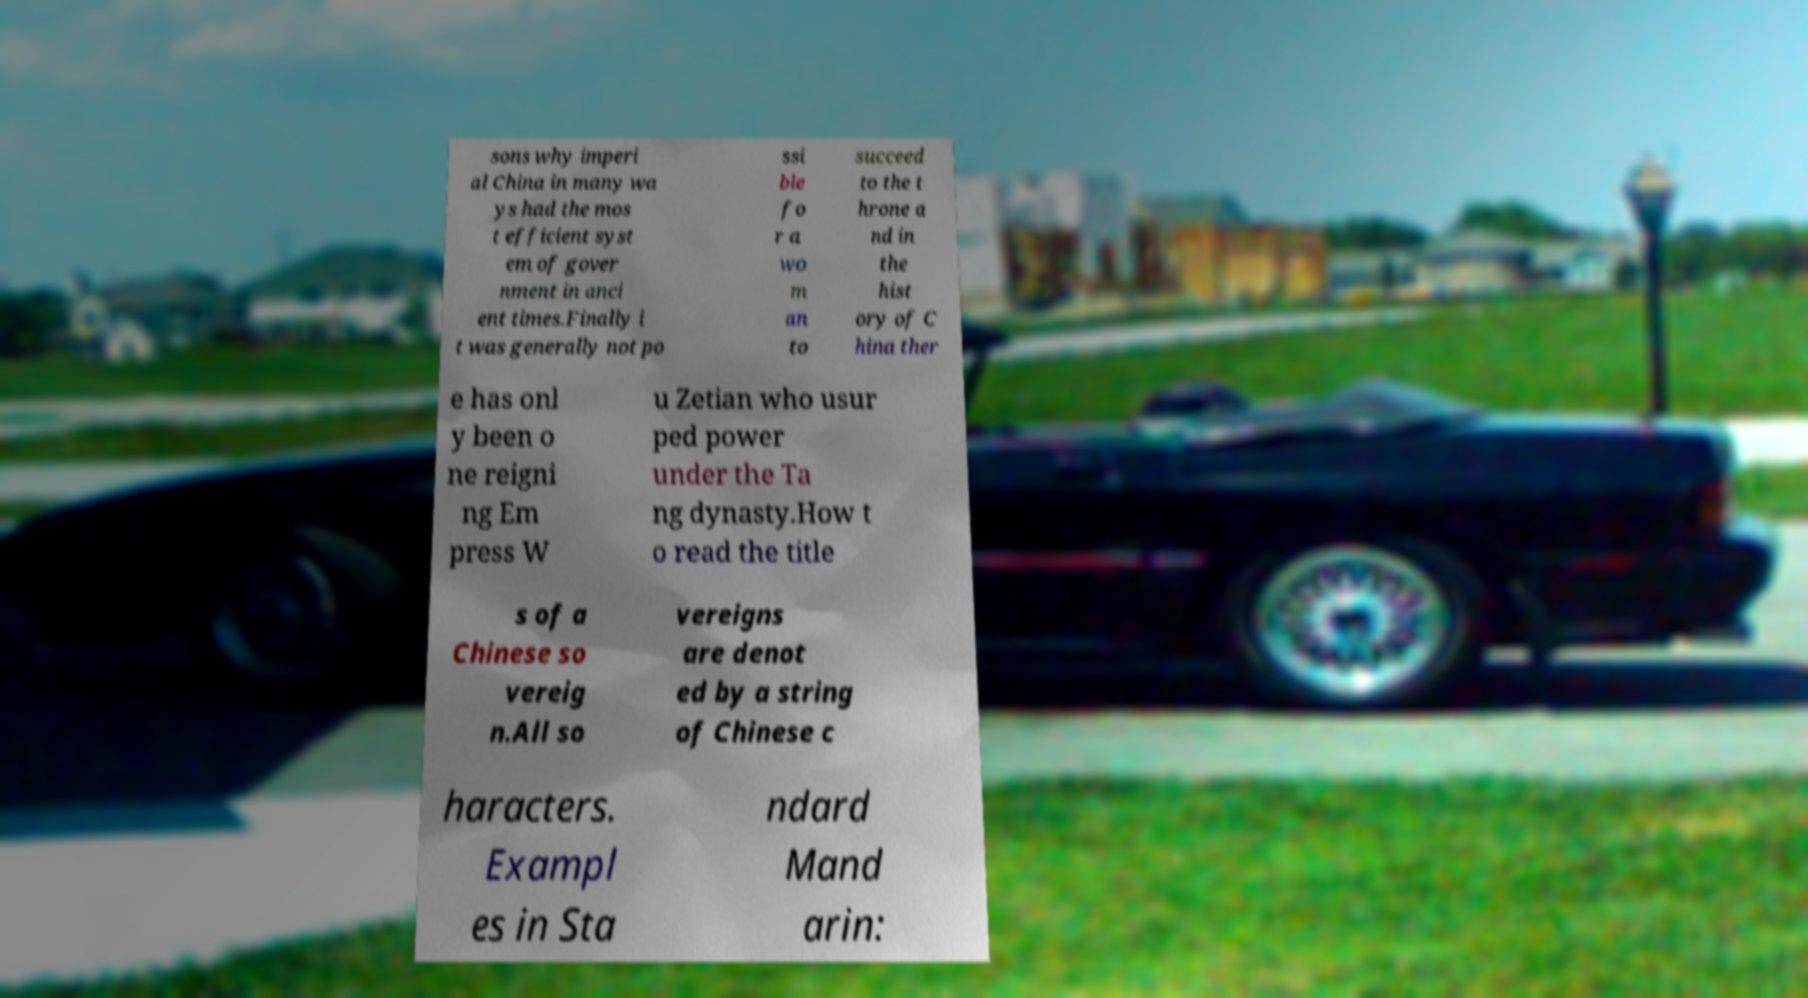Could you assist in decoding the text presented in this image and type it out clearly? sons why imperi al China in many wa ys had the mos t efficient syst em of gover nment in anci ent times.Finally i t was generally not po ssi ble fo r a wo m an to succeed to the t hrone a nd in the hist ory of C hina ther e has onl y been o ne reigni ng Em press W u Zetian who usur ped power under the Ta ng dynasty.How t o read the title s of a Chinese so vereig n.All so vereigns are denot ed by a string of Chinese c haracters. Exampl es in Sta ndard Mand arin: 